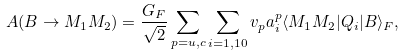Convert formula to latex. <formula><loc_0><loc_0><loc_500><loc_500>A ( B \rightarrow M _ { 1 } M _ { 2 } ) = \frac { G _ { F } } { \sqrt { 2 } } \sum _ { p = u , c } \sum _ { i = 1 , 1 0 } v _ { p } a _ { i } ^ { p } \langle M _ { 1 } M _ { 2 } | Q _ { i } | B \rangle _ { F } ,</formula> 